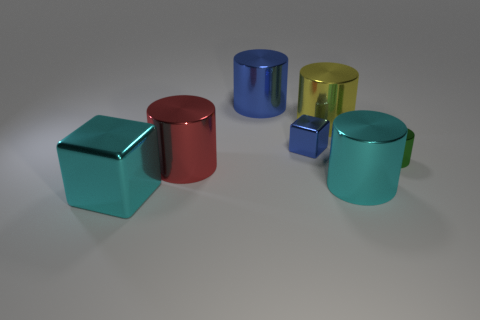Subtract 2 cylinders. How many cylinders are left? 3 Subtract all big red cylinders. How many cylinders are left? 4 Subtract all purple cylinders. Subtract all red spheres. How many cylinders are left? 5 Add 3 small cylinders. How many objects exist? 10 Subtract all cubes. How many objects are left? 5 Subtract 0 cyan balls. How many objects are left? 7 Subtract all blue cylinders. Subtract all green cylinders. How many objects are left? 5 Add 7 green metal things. How many green metal things are left? 8 Add 4 gray matte cubes. How many gray matte cubes exist? 4 